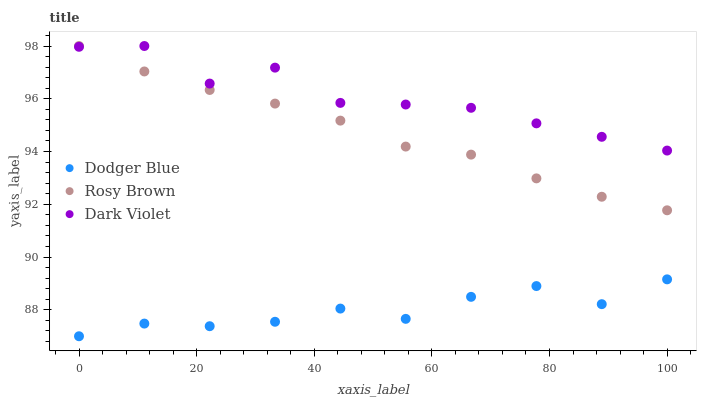Does Dodger Blue have the minimum area under the curve?
Answer yes or no. Yes. Does Dark Violet have the maximum area under the curve?
Answer yes or no. Yes. Does Dark Violet have the minimum area under the curve?
Answer yes or no. No. Does Dodger Blue have the maximum area under the curve?
Answer yes or no. No. Is Rosy Brown the smoothest?
Answer yes or no. Yes. Is Dark Violet the roughest?
Answer yes or no. Yes. Is Dodger Blue the smoothest?
Answer yes or no. No. Is Dodger Blue the roughest?
Answer yes or no. No. Does Dodger Blue have the lowest value?
Answer yes or no. Yes. Does Dark Violet have the lowest value?
Answer yes or no. No. Does Dark Violet have the highest value?
Answer yes or no. Yes. Does Dodger Blue have the highest value?
Answer yes or no. No. Is Dodger Blue less than Rosy Brown?
Answer yes or no. Yes. Is Rosy Brown greater than Dodger Blue?
Answer yes or no. Yes. Does Dark Violet intersect Rosy Brown?
Answer yes or no. Yes. Is Dark Violet less than Rosy Brown?
Answer yes or no. No. Is Dark Violet greater than Rosy Brown?
Answer yes or no. No. Does Dodger Blue intersect Rosy Brown?
Answer yes or no. No. 